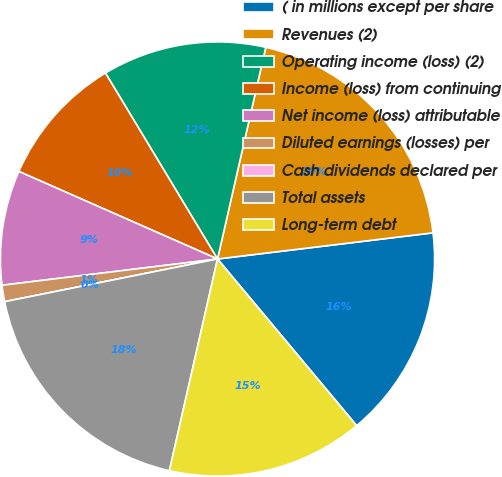Convert chart to OTSL. <chart><loc_0><loc_0><loc_500><loc_500><pie_chart><fcel>( in millions except per share<fcel>Revenues (2)<fcel>Operating income (loss) (2)<fcel>Income (loss) from continuing<fcel>Net income (loss) attributable<fcel>Diluted earnings (losses) per<fcel>Cash dividends declared per<fcel>Total assets<fcel>Long-term debt<nl><fcel>15.85%<fcel>19.51%<fcel>12.2%<fcel>9.76%<fcel>8.54%<fcel>1.22%<fcel>0.0%<fcel>18.29%<fcel>14.63%<nl></chart> 